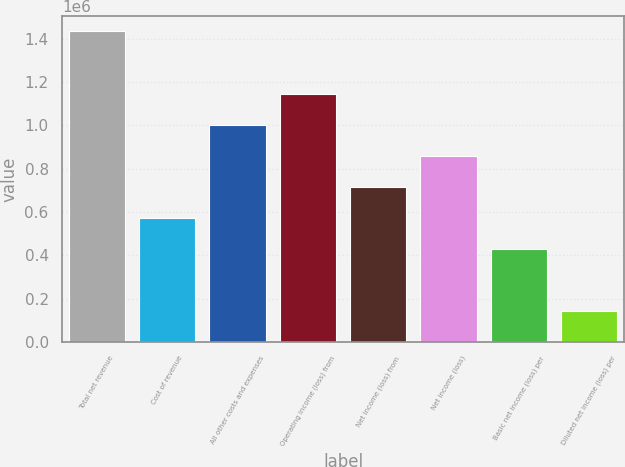Convert chart. <chart><loc_0><loc_0><loc_500><loc_500><bar_chart><fcel>Total net revenue<fcel>Cost of revenue<fcel>All other costs and expenses<fcel>Operating income (loss) from<fcel>Net income (loss) from<fcel>Net income (loss)<fcel>Basic net income (loss) per<fcel>Diluted net income (loss) per<nl><fcel>1.43441e+06<fcel>573764<fcel>1.00409e+06<fcel>1.14753e+06<fcel>717205<fcel>860645<fcel>430323<fcel>143442<nl></chart> 